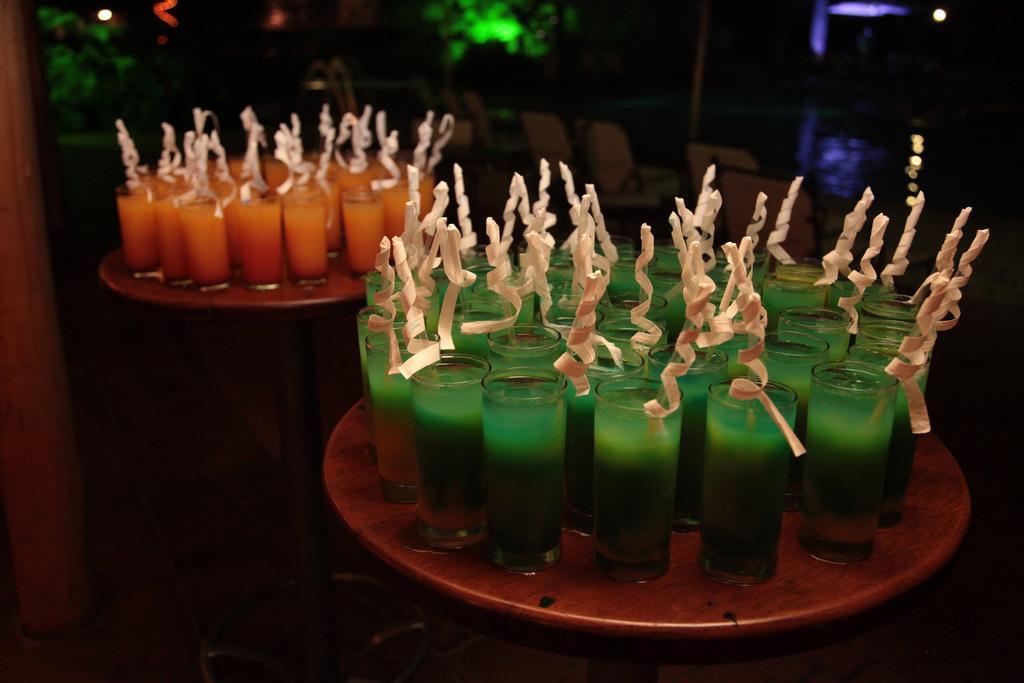Describe this image in one or two sentences. In this picture we can see glasses with drinks in it and these glasses are on tables and in the background we can see chairs and some objects. 